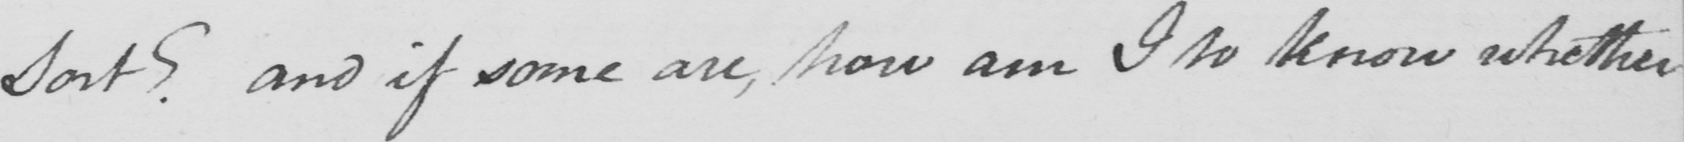What is written in this line of handwriting? Sort ?  and if some are , how am I to know whether 